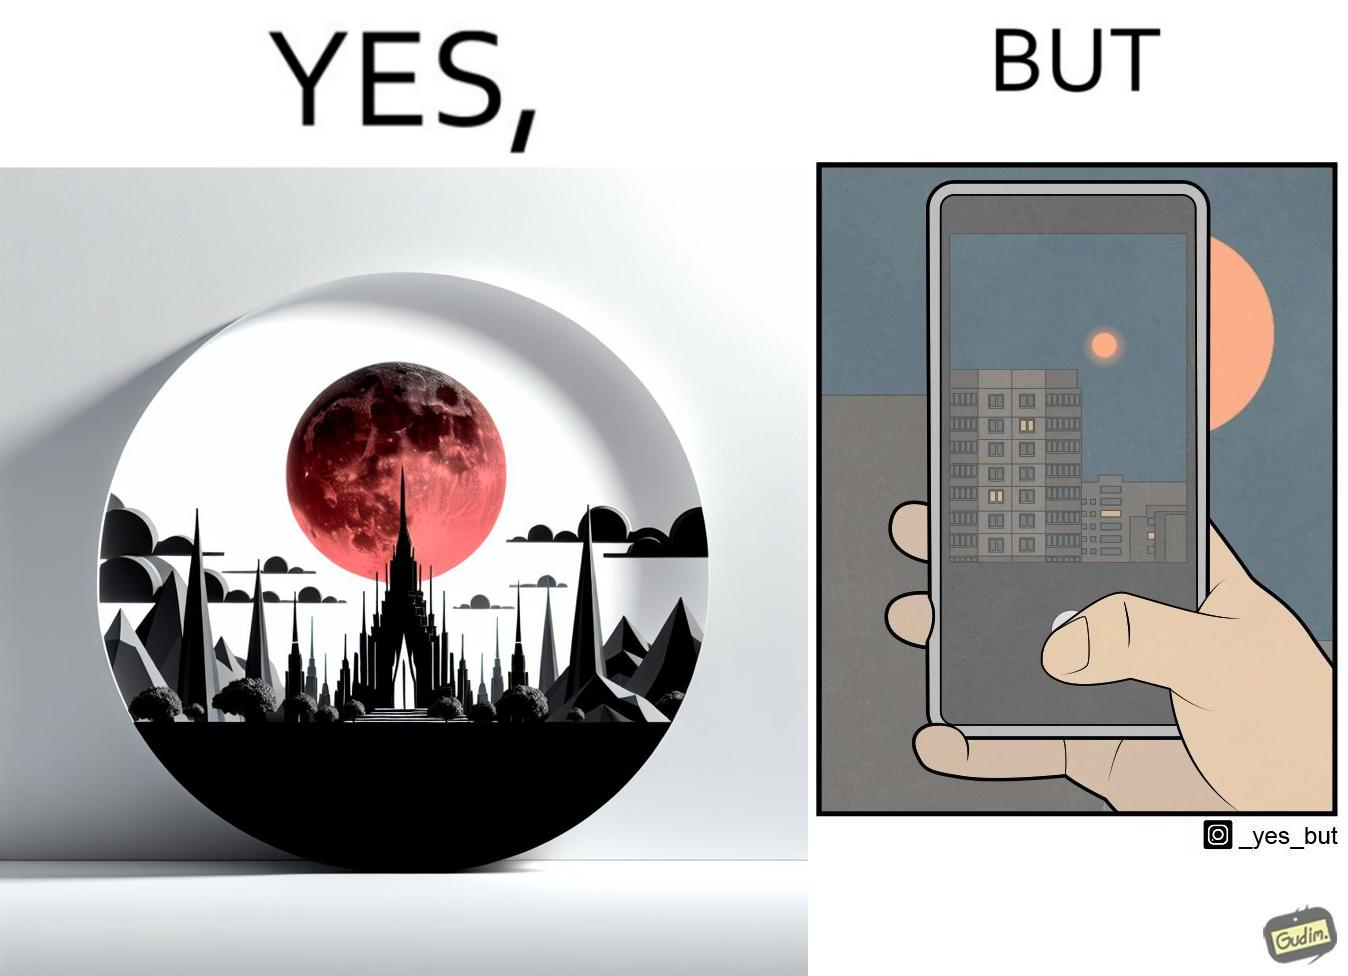What is shown in this image? The image is ironic, because the phone is not able to capture the real beauty of the view which the viewer can see by their naked eyes 